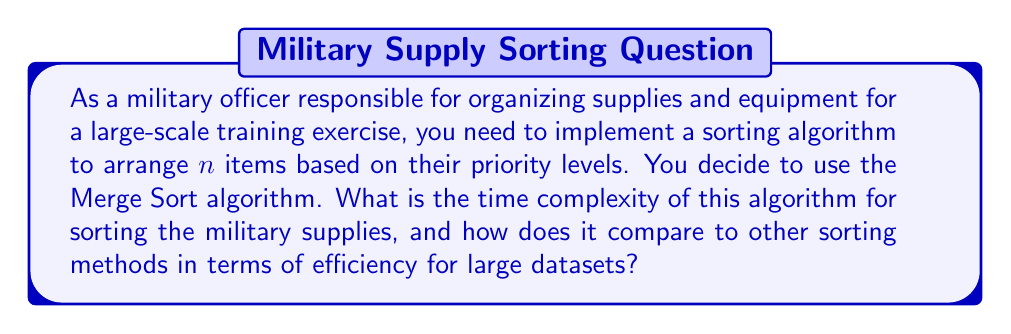Can you solve this math problem? To evaluate the time complexity of the Merge Sort algorithm for organizing military supplies, let's break down the process:

1. Merge Sort is a divide-and-conquer algorithm that works by recursively dividing the list into smaller sublists until each sublist contains only one element.

2. The division process can be represented as a binary tree, where each level splits the previous level's sublists in half. The number of levels in this tree is $\log_2 n$, where $n$ is the number of items.

3. At each level of the tree, the algorithm performs a merging operation. This merge operation compares and combines the sublists, which takes $O(n)$ time in total for each level.

4. The overall time complexity is the product of the number of levels and the time taken at each level:

   $$T(n) = O(n \log n)$$

5. To compare with other sorting algorithms:
   - Quick Sort: Average case $O(n \log n)$, worst case $O(n^2)$
   - Heap Sort: $O(n \log n)$
   - Bubble Sort, Insertion Sort, Selection Sort: $O(n^2)$

6. For large datasets, like organizing extensive military supplies, Merge Sort is highly efficient. It consistently performs at $O(n \log n)$ regardless of the initial order of the items, making it reliable for various scenarios in military logistics.

7. Merge Sort's efficiency comes at the cost of additional space complexity of $O(n)$, which might be a consideration when dealing with limited storage resources in field operations.
Answer: The time complexity of Merge Sort for organizing military supplies is $O(n \log n)$, which is efficient for large datasets and provides consistent performance regardless of the initial order of items. 